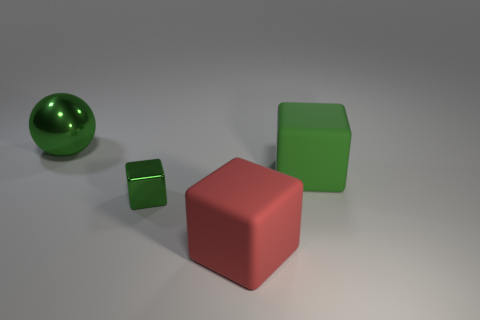How many other tiny metallic things have the same shape as the small green object?
Give a very brief answer. 0. There is another big cube that is the same color as the shiny block; what is it made of?
Ensure brevity in your answer.  Rubber. Is the size of the green thing that is on the right side of the red rubber cube the same as the green shiny ball that is behind the red object?
Your answer should be compact. Yes. What shape is the large green object left of the red object?
Your answer should be very brief. Sphere. What material is the other red object that is the same shape as the small metal object?
Your answer should be very brief. Rubber. Is the size of the thing that is on the right side of the red object the same as the big red cube?
Your response must be concise. Yes. There is a green sphere; how many red blocks are on the left side of it?
Your answer should be compact. 0. Are there fewer large metal balls that are to the left of the sphere than red things that are in front of the small green metallic cube?
Ensure brevity in your answer.  Yes. How many large green shiny balls are there?
Keep it short and to the point. 1. What color is the big matte cube that is behind the shiny block?
Your answer should be very brief. Green. 